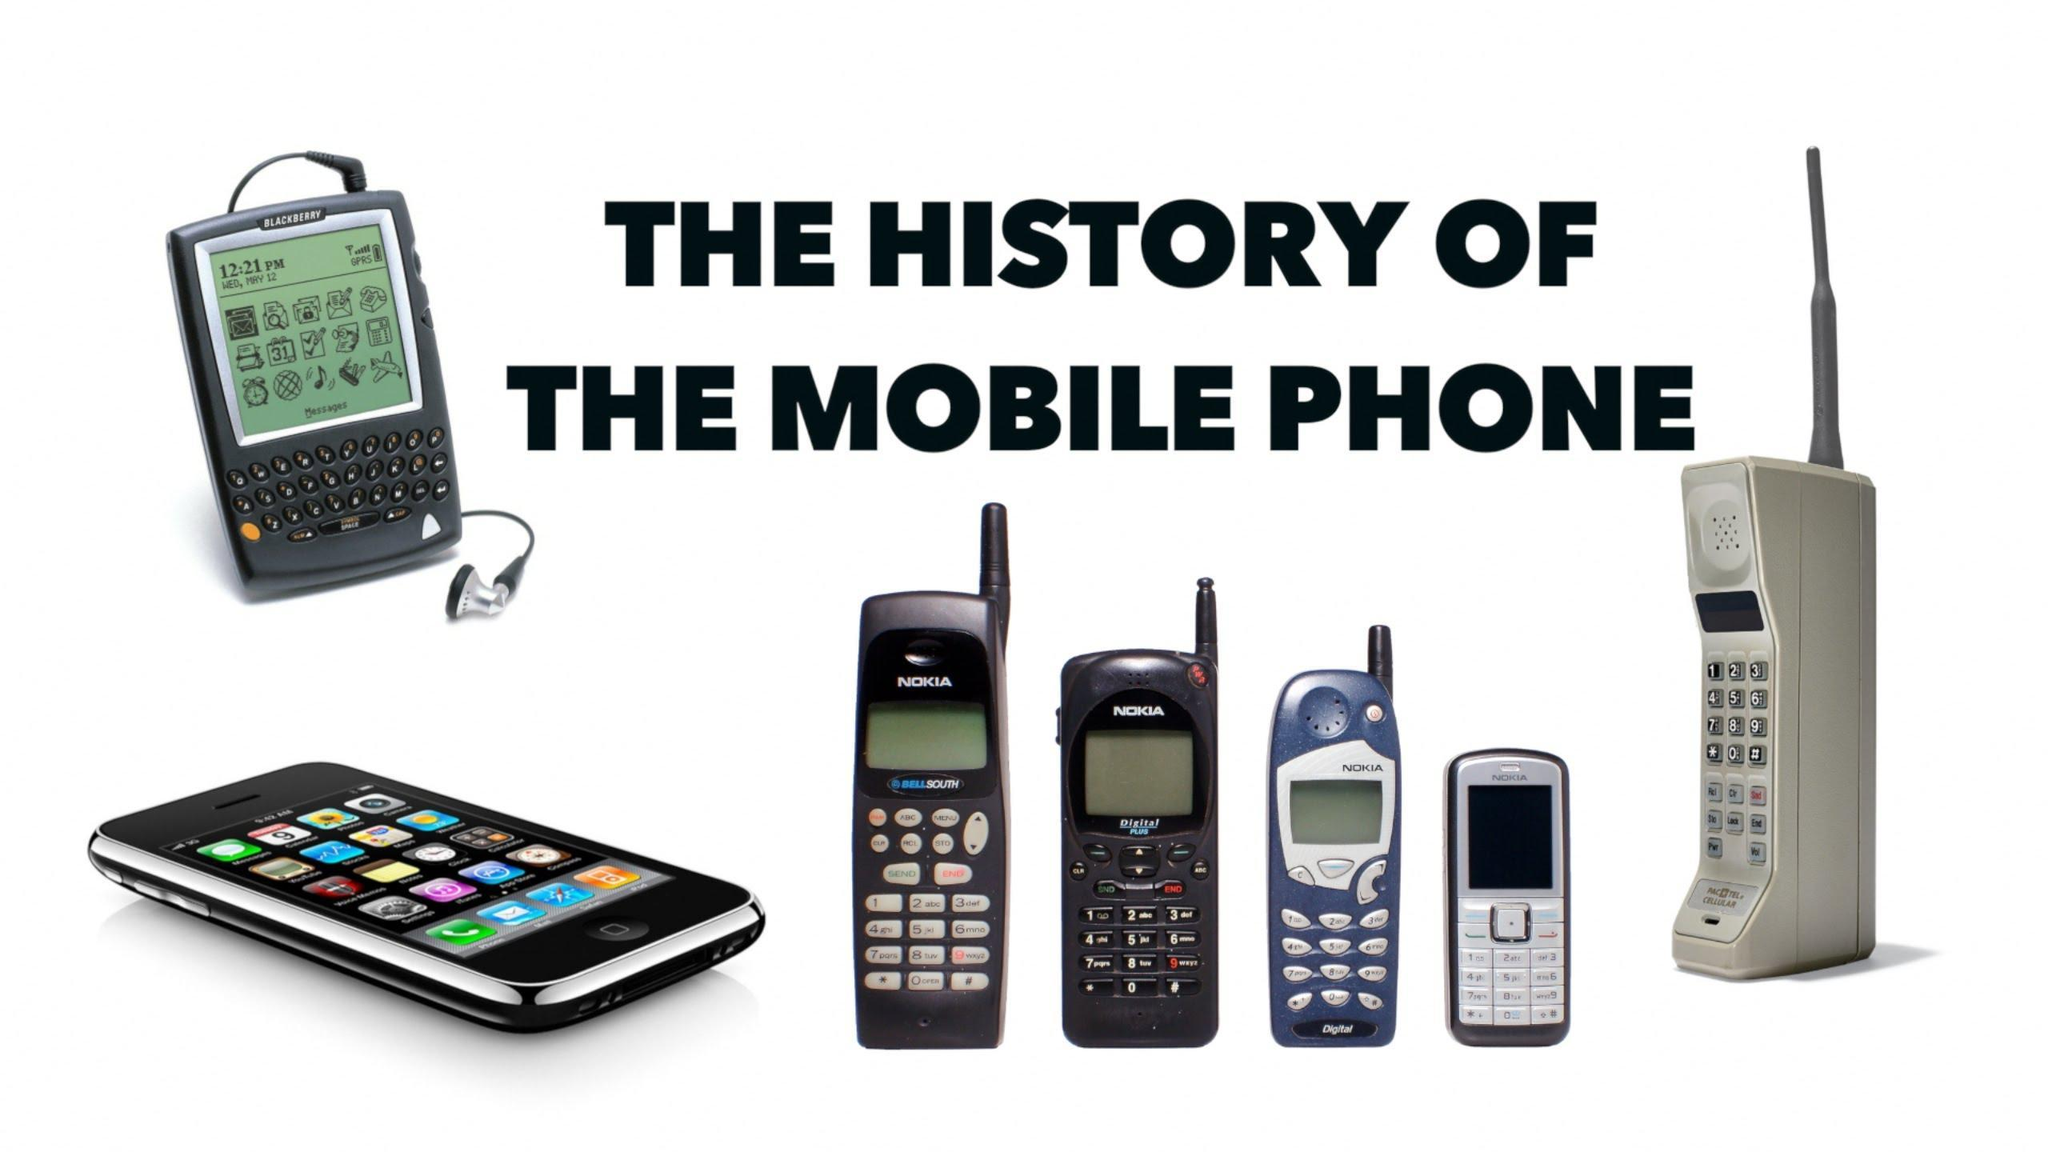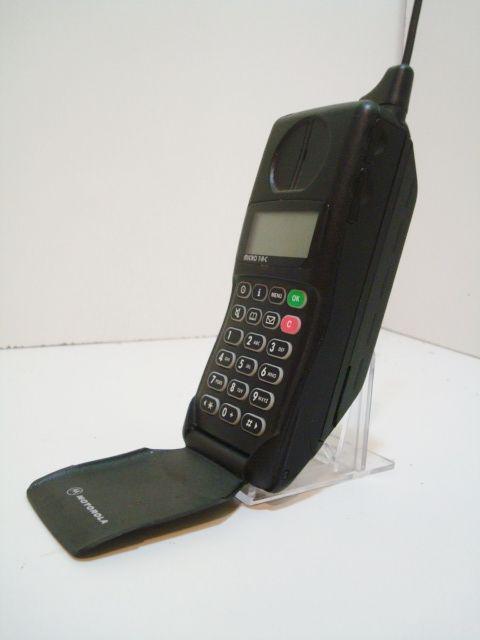The first image is the image on the left, the second image is the image on the right. Given the left and right images, does the statement "Each image contains only a single phone with an antennae on top and a flat, rectangular base." hold true? Answer yes or no. No. The first image is the image on the left, the second image is the image on the right. For the images displayed, is the sentence "The left and right image contains the same number of phones." factually correct? Answer yes or no. No. 